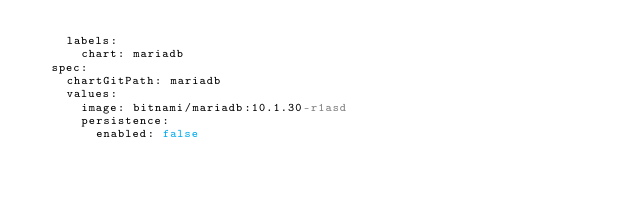<code> <loc_0><loc_0><loc_500><loc_500><_YAML_>    labels:
      chart: mariadb
  spec:
    chartGitPath: mariadb
    values:
      image: bitnami/mariadb:10.1.30-r1asd
      persistence:
        enabled: false
</code> 